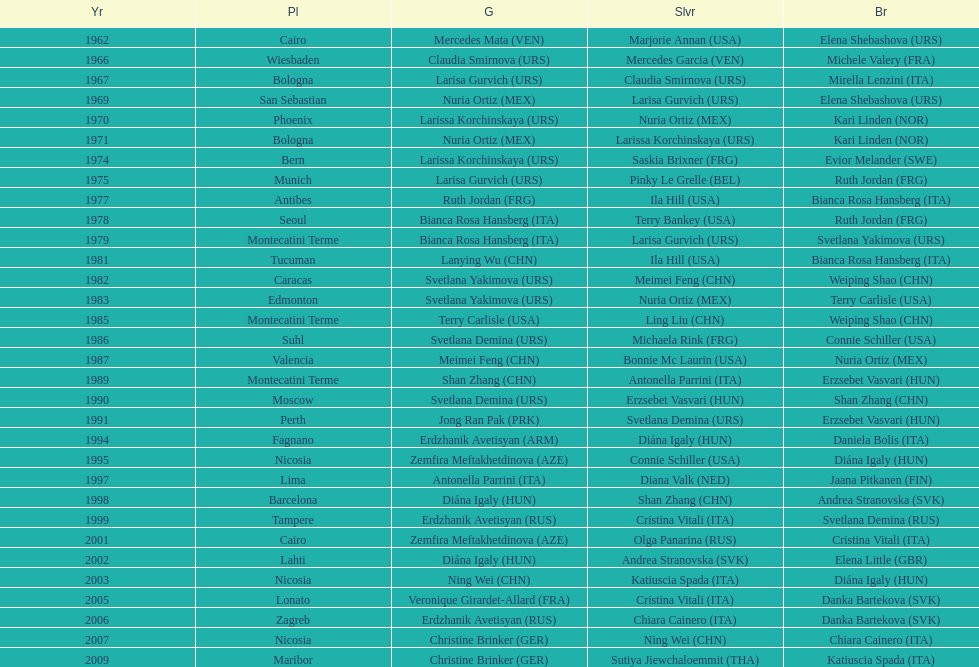What is the total amount of winnings for the united states in gold, silver and bronze? 9. 